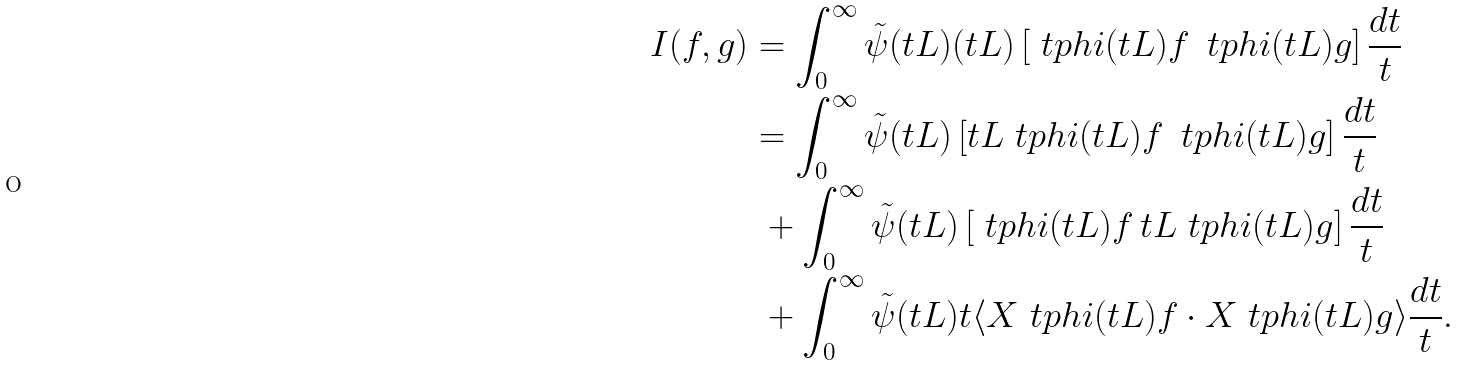<formula> <loc_0><loc_0><loc_500><loc_500>I ( f , g ) & = \int _ { 0 } ^ { \infty } \tilde { \psi } ( t L ) ( t L ) \left [ \ t p h i ( t L ) f \, \ t p h i ( t L ) g \right ] \frac { d t } { t } \\ & = \int _ { 0 } ^ { \infty } \tilde { \psi } ( t L ) \left [ t L \ t p h i ( t L ) f \, \ t p h i ( t L ) g \right ] \frac { d t } { t } \\ & \ + \int _ { 0 } ^ { \infty } \tilde { \psi } ( t L ) \left [ \ t p h i ( t L ) f \, t L \ t p h i ( t L ) g \right ] \frac { d t } { t } \\ & \ + \int _ { 0 } ^ { \infty } \tilde { \psi } ( t L ) t \langle X \ t p h i ( t L ) f \cdot X \ t p h i ( t L ) g \rangle \frac { d t } { t } .</formula> 